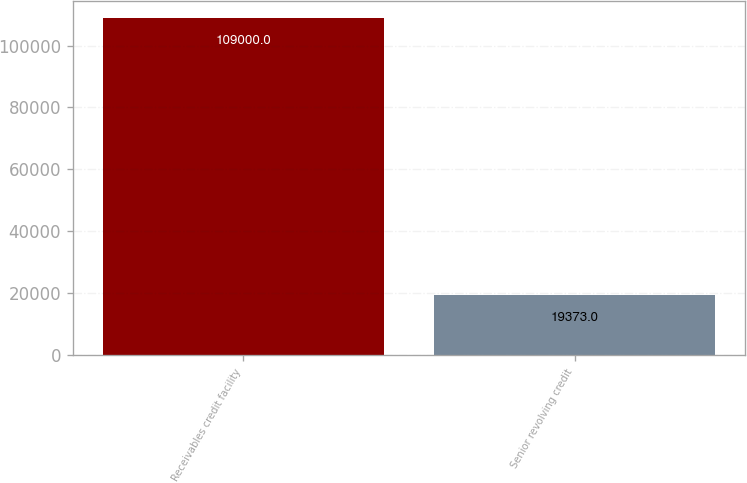<chart> <loc_0><loc_0><loc_500><loc_500><bar_chart><fcel>Receivables credit facility<fcel>Senior revolving credit<nl><fcel>109000<fcel>19373<nl></chart> 